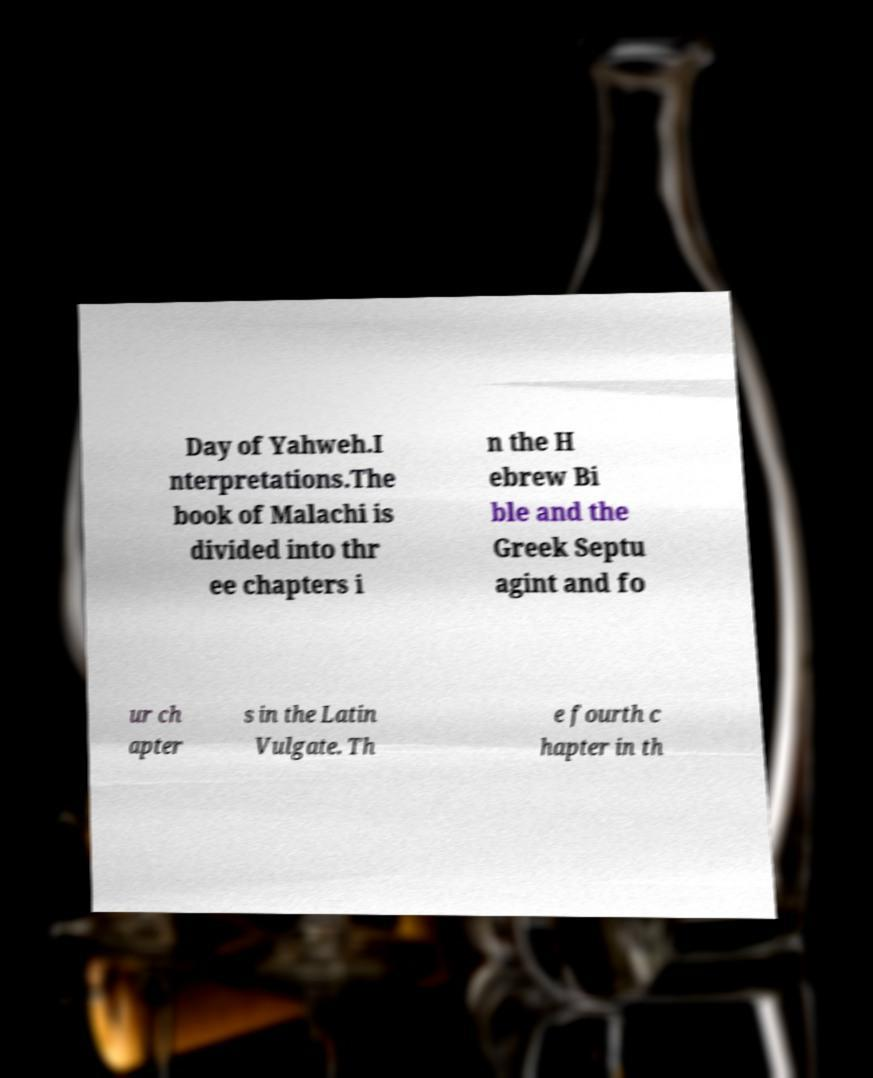Can you accurately transcribe the text from the provided image for me? Day of Yahweh.I nterpretations.The book of Malachi is divided into thr ee chapters i n the H ebrew Bi ble and the Greek Septu agint and fo ur ch apter s in the Latin Vulgate. Th e fourth c hapter in th 